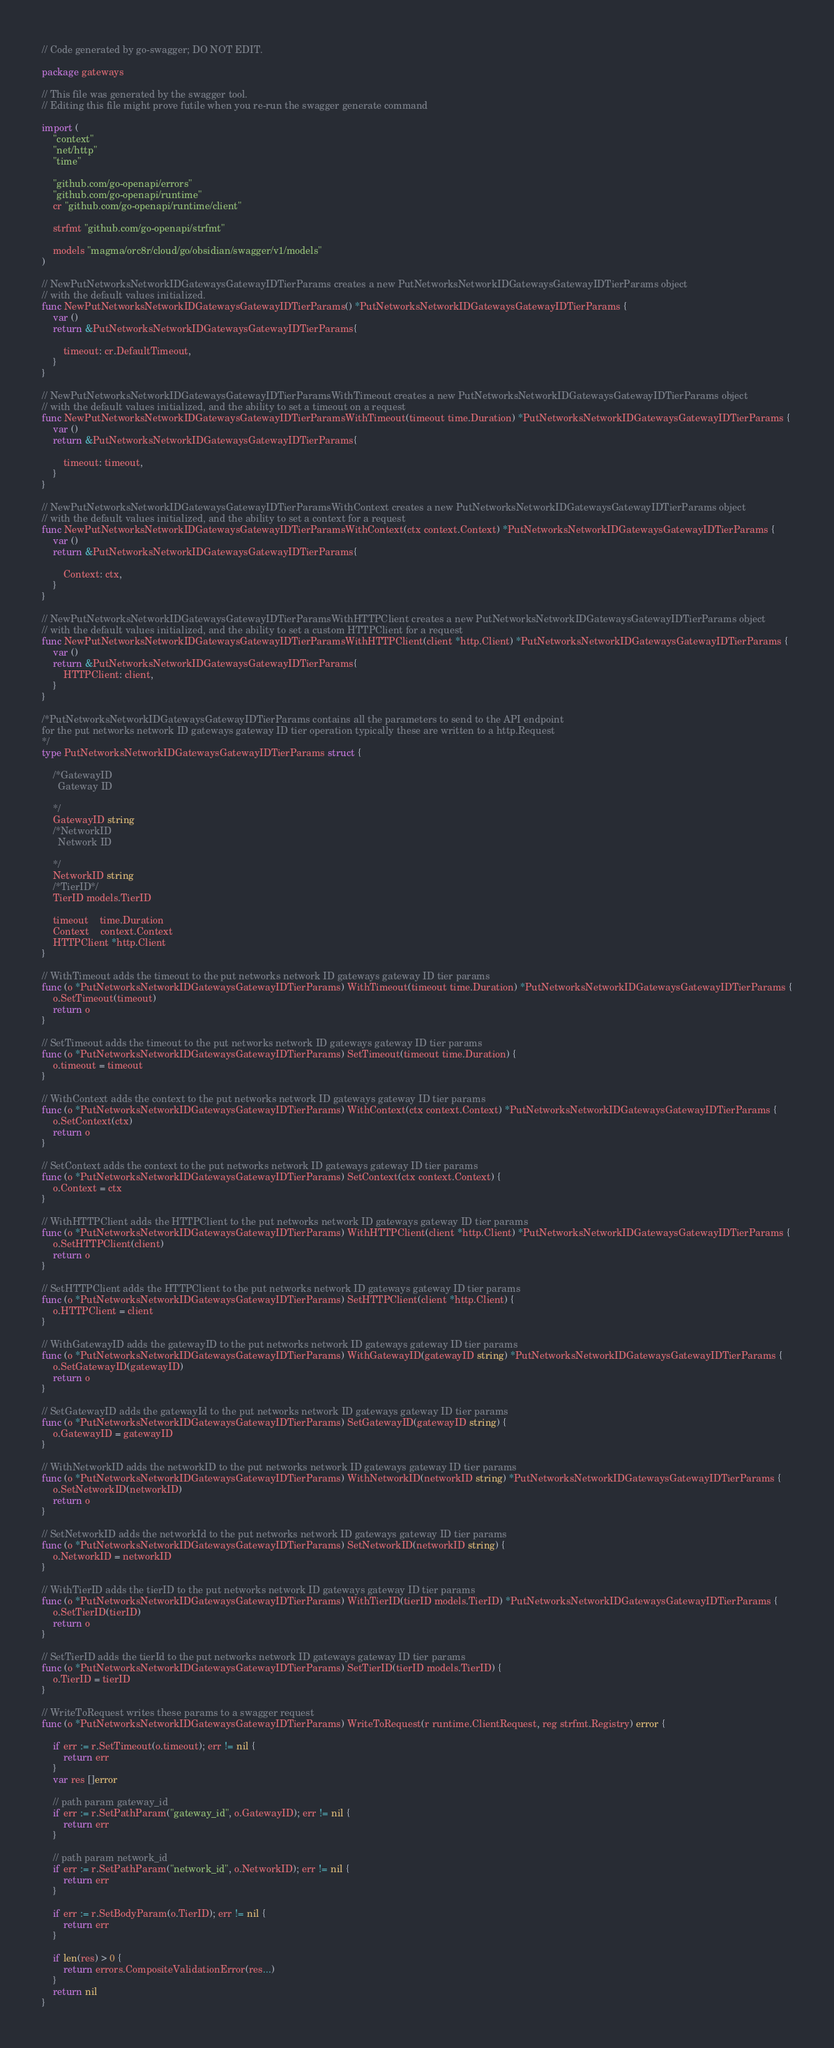<code> <loc_0><loc_0><loc_500><loc_500><_Go_>// Code generated by go-swagger; DO NOT EDIT.

package gateways

// This file was generated by the swagger tool.
// Editing this file might prove futile when you re-run the swagger generate command

import (
	"context"
	"net/http"
	"time"

	"github.com/go-openapi/errors"
	"github.com/go-openapi/runtime"
	cr "github.com/go-openapi/runtime/client"

	strfmt "github.com/go-openapi/strfmt"

	models "magma/orc8r/cloud/go/obsidian/swagger/v1/models"
)

// NewPutNetworksNetworkIDGatewaysGatewayIDTierParams creates a new PutNetworksNetworkIDGatewaysGatewayIDTierParams object
// with the default values initialized.
func NewPutNetworksNetworkIDGatewaysGatewayIDTierParams() *PutNetworksNetworkIDGatewaysGatewayIDTierParams {
	var ()
	return &PutNetworksNetworkIDGatewaysGatewayIDTierParams{

		timeout: cr.DefaultTimeout,
	}
}

// NewPutNetworksNetworkIDGatewaysGatewayIDTierParamsWithTimeout creates a new PutNetworksNetworkIDGatewaysGatewayIDTierParams object
// with the default values initialized, and the ability to set a timeout on a request
func NewPutNetworksNetworkIDGatewaysGatewayIDTierParamsWithTimeout(timeout time.Duration) *PutNetworksNetworkIDGatewaysGatewayIDTierParams {
	var ()
	return &PutNetworksNetworkIDGatewaysGatewayIDTierParams{

		timeout: timeout,
	}
}

// NewPutNetworksNetworkIDGatewaysGatewayIDTierParamsWithContext creates a new PutNetworksNetworkIDGatewaysGatewayIDTierParams object
// with the default values initialized, and the ability to set a context for a request
func NewPutNetworksNetworkIDGatewaysGatewayIDTierParamsWithContext(ctx context.Context) *PutNetworksNetworkIDGatewaysGatewayIDTierParams {
	var ()
	return &PutNetworksNetworkIDGatewaysGatewayIDTierParams{

		Context: ctx,
	}
}

// NewPutNetworksNetworkIDGatewaysGatewayIDTierParamsWithHTTPClient creates a new PutNetworksNetworkIDGatewaysGatewayIDTierParams object
// with the default values initialized, and the ability to set a custom HTTPClient for a request
func NewPutNetworksNetworkIDGatewaysGatewayIDTierParamsWithHTTPClient(client *http.Client) *PutNetworksNetworkIDGatewaysGatewayIDTierParams {
	var ()
	return &PutNetworksNetworkIDGatewaysGatewayIDTierParams{
		HTTPClient: client,
	}
}

/*PutNetworksNetworkIDGatewaysGatewayIDTierParams contains all the parameters to send to the API endpoint
for the put networks network ID gateways gateway ID tier operation typically these are written to a http.Request
*/
type PutNetworksNetworkIDGatewaysGatewayIDTierParams struct {

	/*GatewayID
	  Gateway ID

	*/
	GatewayID string
	/*NetworkID
	  Network ID

	*/
	NetworkID string
	/*TierID*/
	TierID models.TierID

	timeout    time.Duration
	Context    context.Context
	HTTPClient *http.Client
}

// WithTimeout adds the timeout to the put networks network ID gateways gateway ID tier params
func (o *PutNetworksNetworkIDGatewaysGatewayIDTierParams) WithTimeout(timeout time.Duration) *PutNetworksNetworkIDGatewaysGatewayIDTierParams {
	o.SetTimeout(timeout)
	return o
}

// SetTimeout adds the timeout to the put networks network ID gateways gateway ID tier params
func (o *PutNetworksNetworkIDGatewaysGatewayIDTierParams) SetTimeout(timeout time.Duration) {
	o.timeout = timeout
}

// WithContext adds the context to the put networks network ID gateways gateway ID tier params
func (o *PutNetworksNetworkIDGatewaysGatewayIDTierParams) WithContext(ctx context.Context) *PutNetworksNetworkIDGatewaysGatewayIDTierParams {
	o.SetContext(ctx)
	return o
}

// SetContext adds the context to the put networks network ID gateways gateway ID tier params
func (o *PutNetworksNetworkIDGatewaysGatewayIDTierParams) SetContext(ctx context.Context) {
	o.Context = ctx
}

// WithHTTPClient adds the HTTPClient to the put networks network ID gateways gateway ID tier params
func (o *PutNetworksNetworkIDGatewaysGatewayIDTierParams) WithHTTPClient(client *http.Client) *PutNetworksNetworkIDGatewaysGatewayIDTierParams {
	o.SetHTTPClient(client)
	return o
}

// SetHTTPClient adds the HTTPClient to the put networks network ID gateways gateway ID tier params
func (o *PutNetworksNetworkIDGatewaysGatewayIDTierParams) SetHTTPClient(client *http.Client) {
	o.HTTPClient = client
}

// WithGatewayID adds the gatewayID to the put networks network ID gateways gateway ID tier params
func (o *PutNetworksNetworkIDGatewaysGatewayIDTierParams) WithGatewayID(gatewayID string) *PutNetworksNetworkIDGatewaysGatewayIDTierParams {
	o.SetGatewayID(gatewayID)
	return o
}

// SetGatewayID adds the gatewayId to the put networks network ID gateways gateway ID tier params
func (o *PutNetworksNetworkIDGatewaysGatewayIDTierParams) SetGatewayID(gatewayID string) {
	o.GatewayID = gatewayID
}

// WithNetworkID adds the networkID to the put networks network ID gateways gateway ID tier params
func (o *PutNetworksNetworkIDGatewaysGatewayIDTierParams) WithNetworkID(networkID string) *PutNetworksNetworkIDGatewaysGatewayIDTierParams {
	o.SetNetworkID(networkID)
	return o
}

// SetNetworkID adds the networkId to the put networks network ID gateways gateway ID tier params
func (o *PutNetworksNetworkIDGatewaysGatewayIDTierParams) SetNetworkID(networkID string) {
	o.NetworkID = networkID
}

// WithTierID adds the tierID to the put networks network ID gateways gateway ID tier params
func (o *PutNetworksNetworkIDGatewaysGatewayIDTierParams) WithTierID(tierID models.TierID) *PutNetworksNetworkIDGatewaysGatewayIDTierParams {
	o.SetTierID(tierID)
	return o
}

// SetTierID adds the tierId to the put networks network ID gateways gateway ID tier params
func (o *PutNetworksNetworkIDGatewaysGatewayIDTierParams) SetTierID(tierID models.TierID) {
	o.TierID = tierID
}

// WriteToRequest writes these params to a swagger request
func (o *PutNetworksNetworkIDGatewaysGatewayIDTierParams) WriteToRequest(r runtime.ClientRequest, reg strfmt.Registry) error {

	if err := r.SetTimeout(o.timeout); err != nil {
		return err
	}
	var res []error

	// path param gateway_id
	if err := r.SetPathParam("gateway_id", o.GatewayID); err != nil {
		return err
	}

	// path param network_id
	if err := r.SetPathParam("network_id", o.NetworkID); err != nil {
		return err
	}

	if err := r.SetBodyParam(o.TierID); err != nil {
		return err
	}

	if len(res) > 0 {
		return errors.CompositeValidationError(res...)
	}
	return nil
}
</code> 